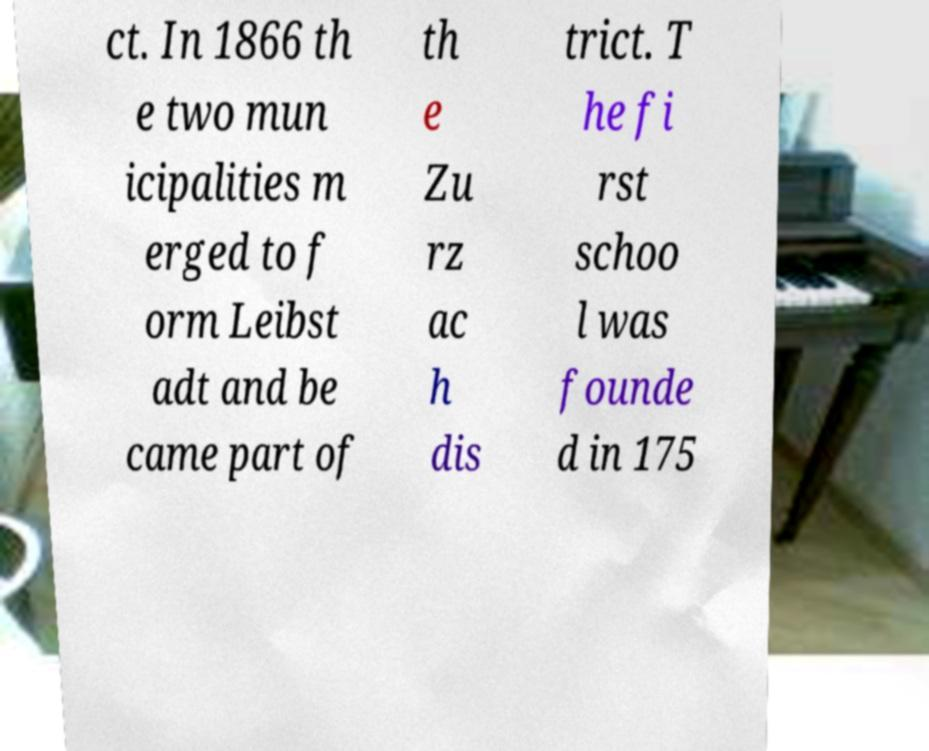Could you assist in decoding the text presented in this image and type it out clearly? ct. In 1866 th e two mun icipalities m erged to f orm Leibst adt and be came part of th e Zu rz ac h dis trict. T he fi rst schoo l was founde d in 175 